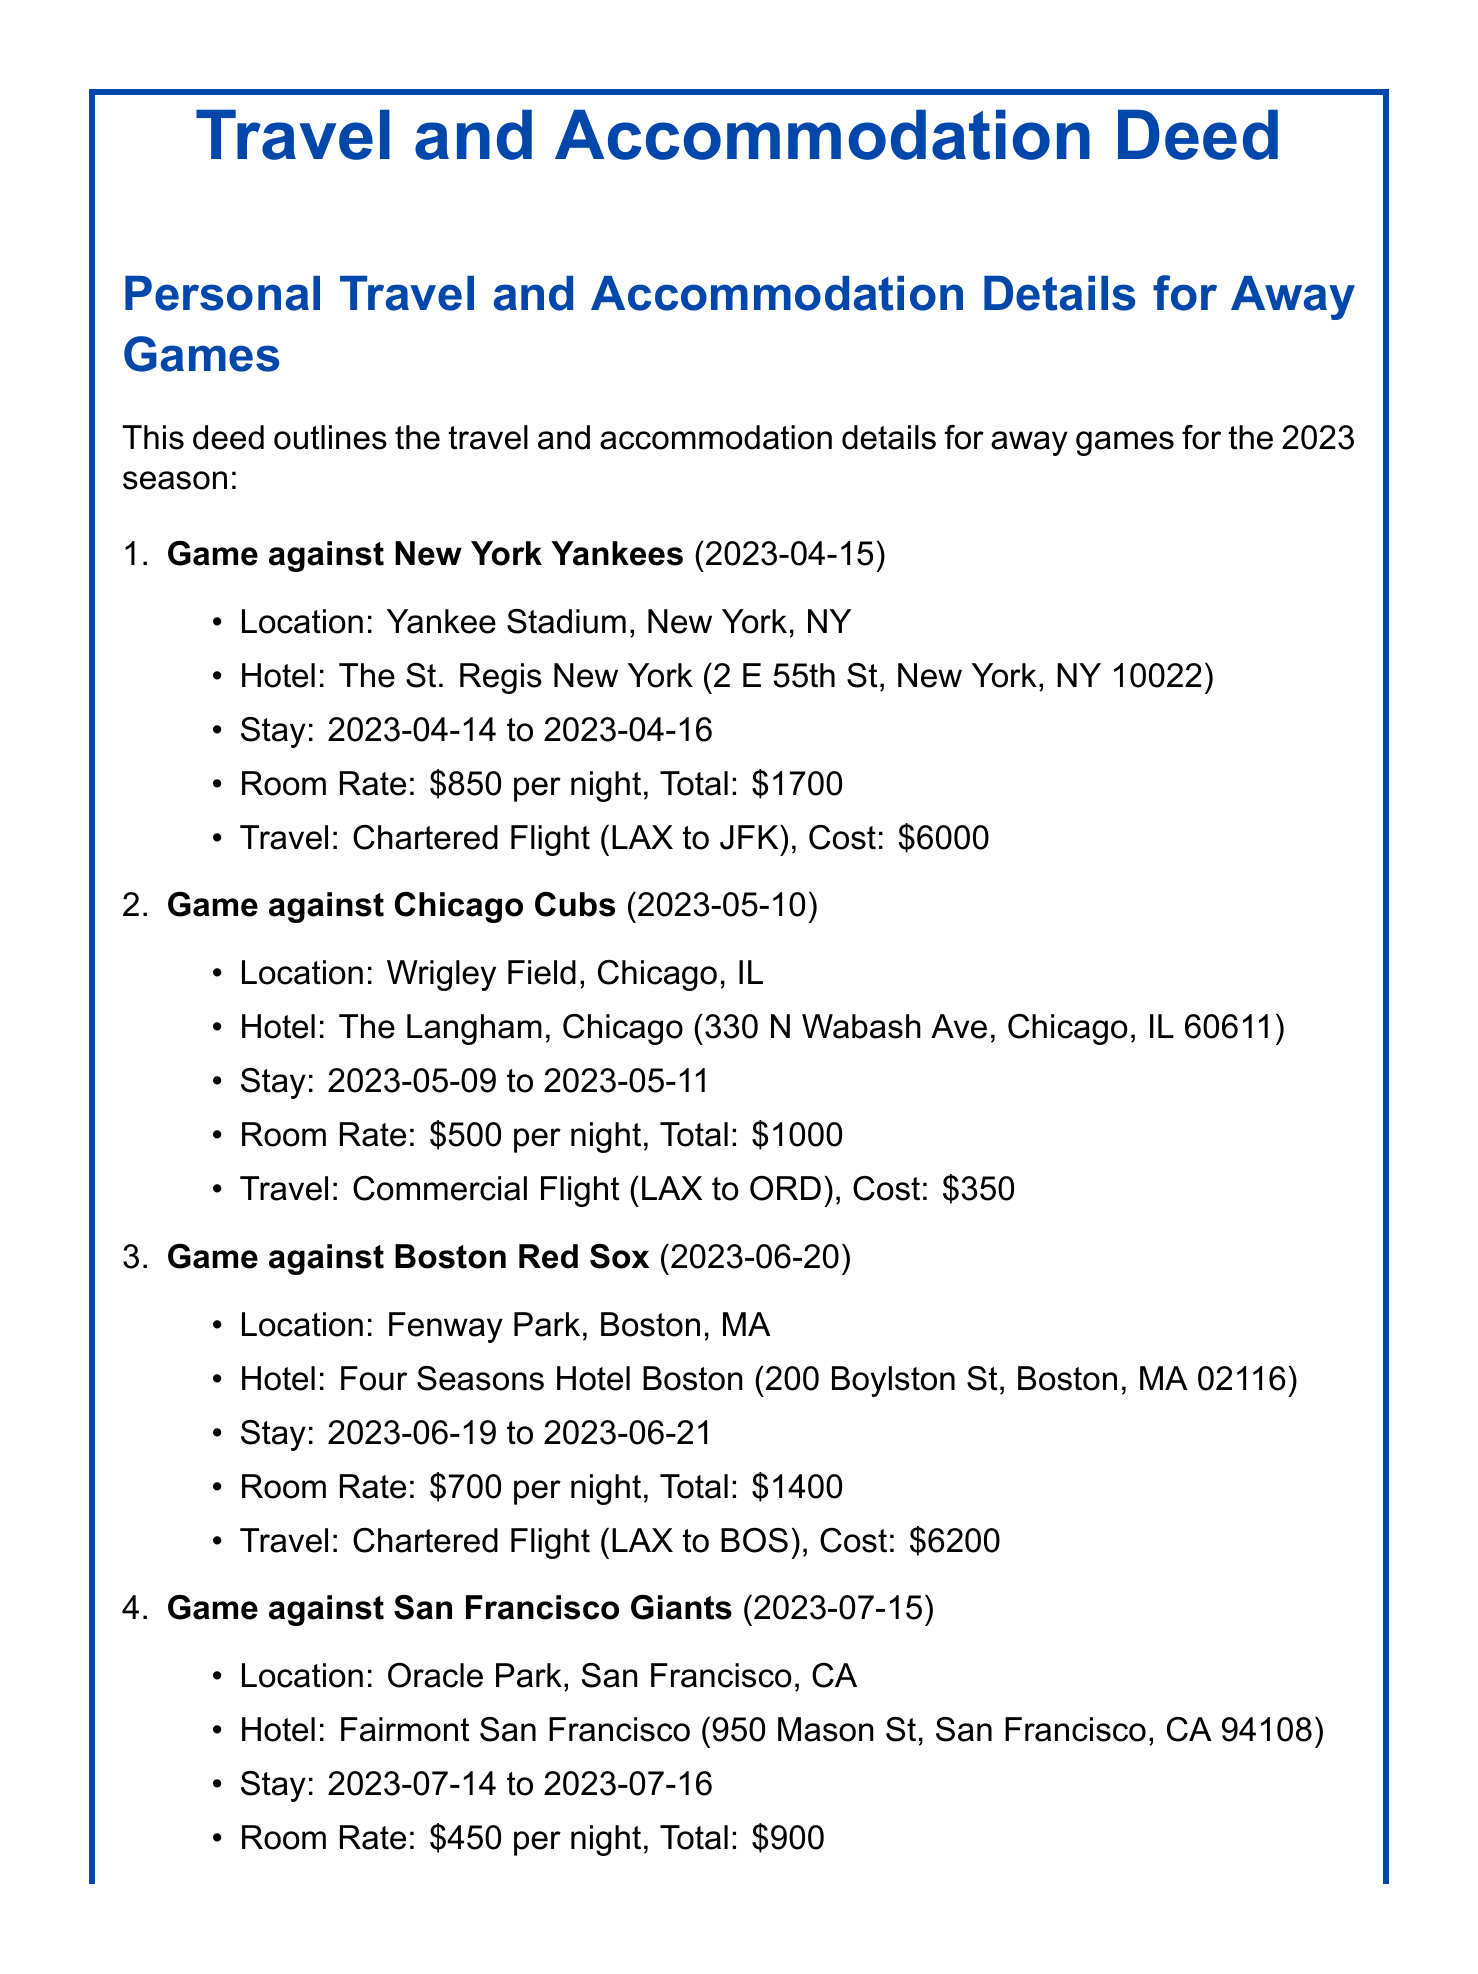what is the location of the game against New York Yankees? The location for the New York Yankees game is listed in the document as Yankee Stadium, New York, NY.
Answer: Yankee Stadium, New York, NY how many nights did the player stay at The Langham in Chicago? The document states the stay at The Langham was from May 9 to May 11, which is two nights.
Answer: 2 nights what was the total accommodation cost for the Boston Red Sox game? The room rate for the Boston game was $700 per night for two nights, making a total of $1400.
Answer: $1400 which hotel was used for the game against the San Francisco Giants? The document specifies that the player stayed at Fairmont San Francisco for the Giants game.
Answer: Fairmont San Francisco what type of flight was taken to the Chicago Cubs game? The document states that the last booking for the Chicago Cubs game was a commercial flight, which indicates the travel method used.
Answer: Commercial Flight how much did the chartered flight to New York Yankees cost? The cost for the chartered flight detailed in the document is $6000.
Answer: $6000 how many games are listed in the deed? There are a total of four games outlined in the document regarding personal travel and accommodation for away games.
Answer: 4 games what is the room rate per night at The St. Regis New York? According to the document, the room rate at The St. Regis New York is $850 per night.
Answer: $850 per night what is the purpose of this document? The deed outlines personal travel and accommodation details for away games, indicating the purpose is to record these expenses and arrangements.
Answer: Personal record only 